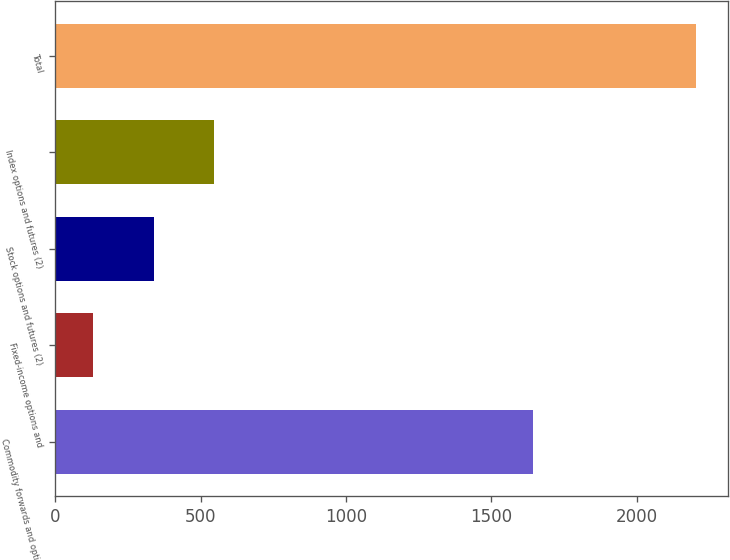Convert chart. <chart><loc_0><loc_0><loc_500><loc_500><bar_chart><fcel>Commodity forwards and options<fcel>Fixed-income options and<fcel>Stock options and futures (2)<fcel>Index options and futures (2)<fcel>Total<nl><fcel>1642<fcel>131<fcel>338.1<fcel>545.2<fcel>2202<nl></chart> 